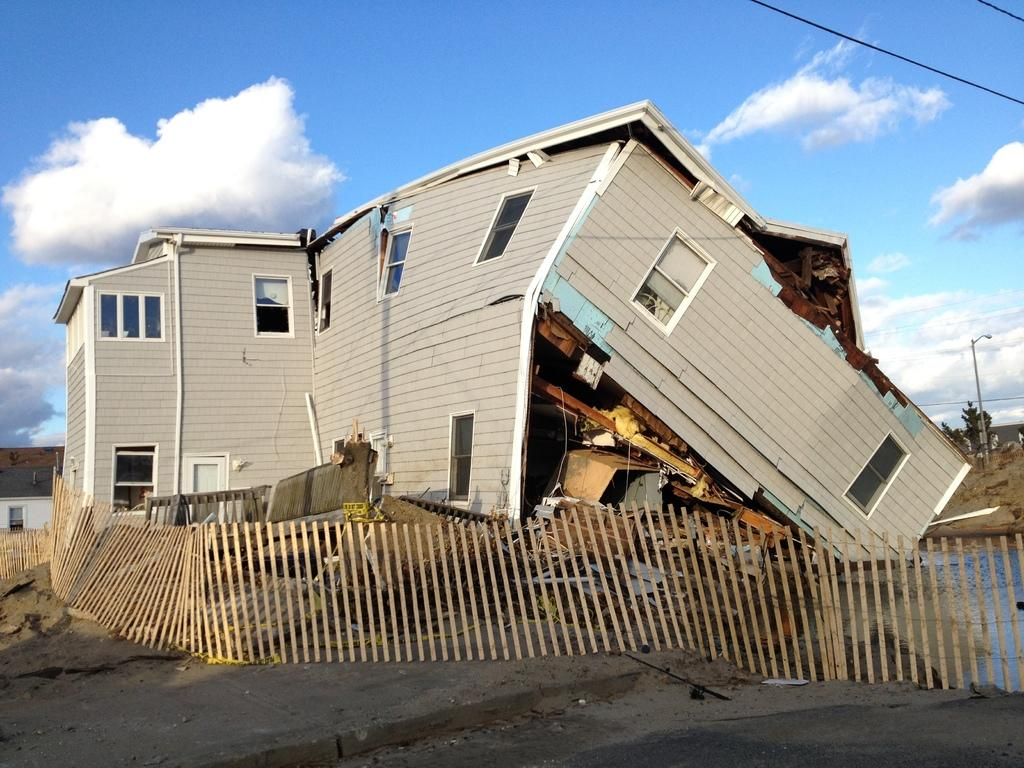What is the main subject of the image? The main subject of the image is a collapsed building. What can be seen at the bottom of the image? There is a fence at the bottom of the image. What type of vegetation is visible in the background of the image? There are trees in the background of the image. What else can be seen in the background of the image? There are wires and a pole in the background of the image. What is visible at the top of the image? The sky is visible at the top of the image. What type of argument can be seen taking place between the collapsed building and the fence in the image? There is no argument present in the image; it features a collapsed building and a fence. Can you tell me how many veins are visible in the collapsed building? There are no veins visible in the collapsed building; it is a structure made of materials like concrete and steel. 